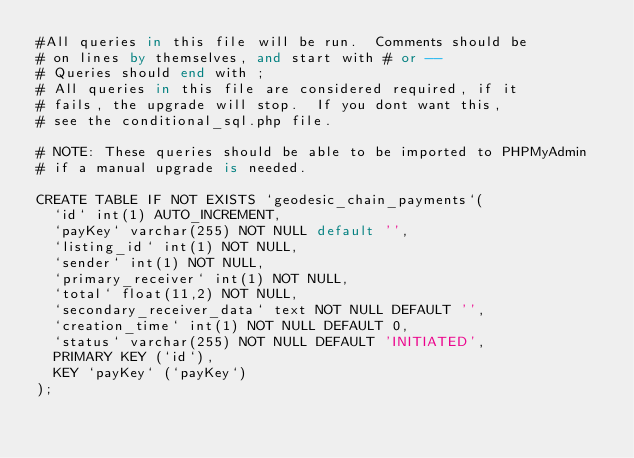<code> <loc_0><loc_0><loc_500><loc_500><_SQL_>#All queries in this file will be run.  Comments should be
# on lines by themselves, and start with # or --
# Queries should end with ;
# All queries in this file are considered required, if it
# fails, the upgrade will stop.  If you dont want this,
# see the conditional_sql.php file.

# NOTE: These queries should be able to be imported to PHPMyAdmin
# if a manual upgrade is needed.

CREATE TABLE IF NOT EXISTS `geodesic_chain_payments`(
	`id` int(1) AUTO_INCREMENT,
	`payKey` varchar(255) NOT NULL default '',
	`listing_id` int(1) NOT NULL,
	`sender` int(1) NOT NULL,
	`primary_receiver` int(1) NOT NULL,
	`total` float(11,2) NOT NULL,
	`secondary_receiver_data` text NOT NULL DEFAULT '',
	`creation_time` int(1) NOT NULL DEFAULT 0,
	`status` varchar(255) NOT NULL DEFAULT 'INITIATED',
	PRIMARY KEY (`id`),
	KEY `payKey` (`payKey`)
);</code> 